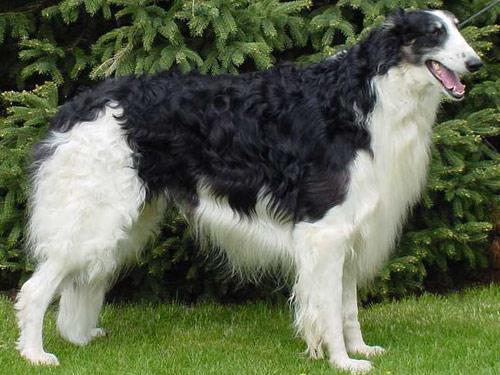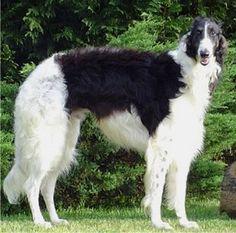The first image is the image on the left, the second image is the image on the right. For the images displayed, is the sentence "Right image shows exactly one black and white hound in profile." factually correct? Answer yes or no. Yes. 